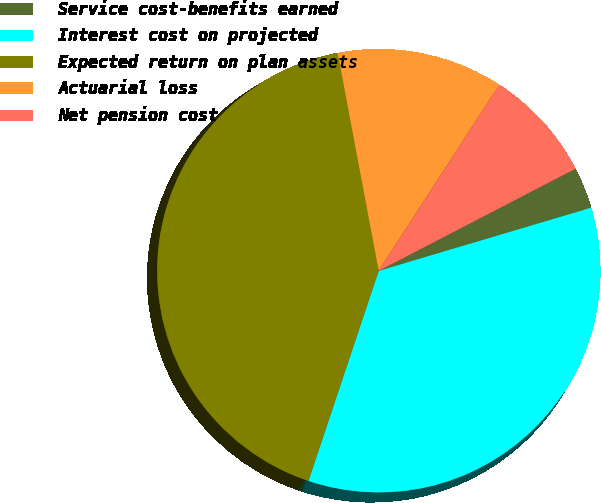Convert chart. <chart><loc_0><loc_0><loc_500><loc_500><pie_chart><fcel>Service cost-benefits earned<fcel>Interest cost on projected<fcel>Expected return on plan assets<fcel>Actuarial loss<fcel>Net pension cost<nl><fcel>3.02%<fcel>34.73%<fcel>41.9%<fcel>12.11%<fcel>8.23%<nl></chart> 